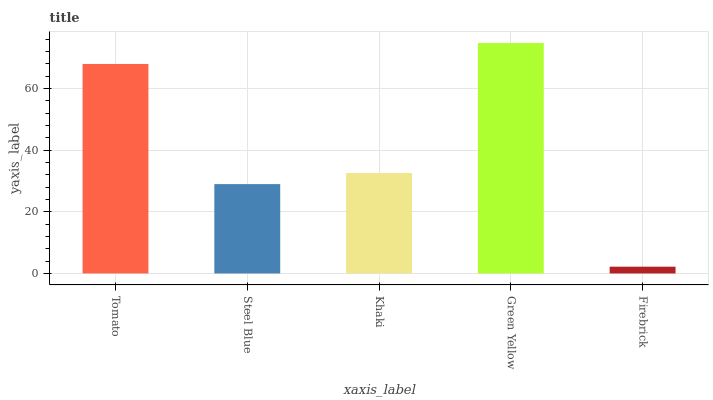Is Firebrick the minimum?
Answer yes or no. Yes. Is Green Yellow the maximum?
Answer yes or no. Yes. Is Steel Blue the minimum?
Answer yes or no. No. Is Steel Blue the maximum?
Answer yes or no. No. Is Tomato greater than Steel Blue?
Answer yes or no. Yes. Is Steel Blue less than Tomato?
Answer yes or no. Yes. Is Steel Blue greater than Tomato?
Answer yes or no. No. Is Tomato less than Steel Blue?
Answer yes or no. No. Is Khaki the high median?
Answer yes or no. Yes. Is Khaki the low median?
Answer yes or no. Yes. Is Firebrick the high median?
Answer yes or no. No. Is Firebrick the low median?
Answer yes or no. No. 